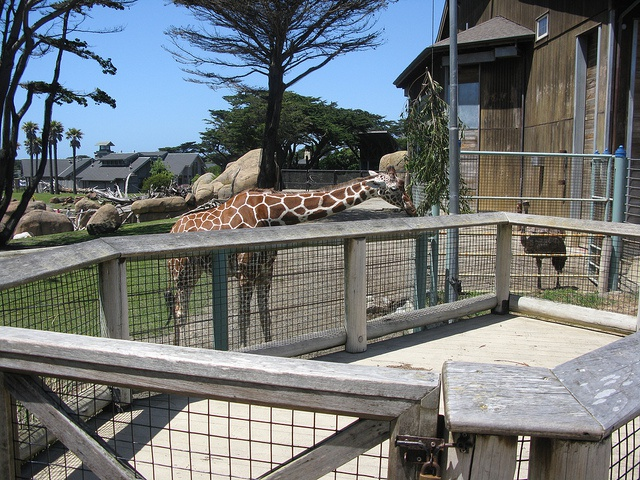Describe the objects in this image and their specific colors. I can see giraffe in black, gray, and maroon tones and bird in black and gray tones in this image. 